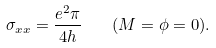Convert formula to latex. <formula><loc_0><loc_0><loc_500><loc_500>\sigma _ { x x } = \frac { e ^ { 2 } \pi } { 4 h } \quad ( M = \phi = 0 ) .</formula> 